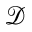<formula> <loc_0><loc_0><loc_500><loc_500>\mathcal { D }</formula> 